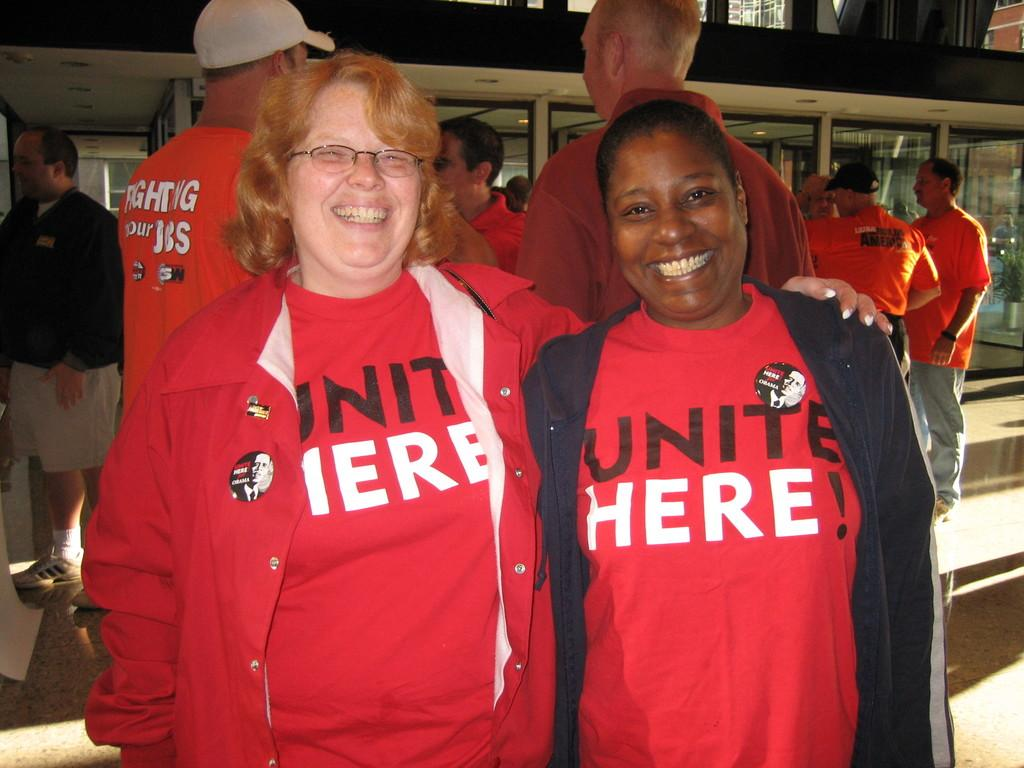Provide a one-sentence caption for the provided image. Two women wearing red Unite Here! shirts are smiling for a photo. 